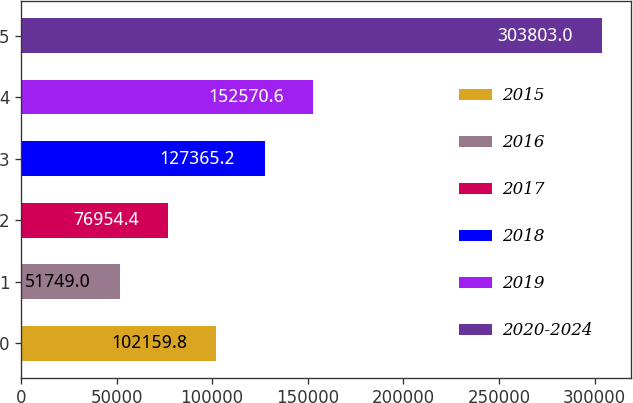Convert chart to OTSL. <chart><loc_0><loc_0><loc_500><loc_500><bar_chart><fcel>2015<fcel>2016<fcel>2017<fcel>2018<fcel>2019<fcel>2020-2024<nl><fcel>102160<fcel>51749<fcel>76954.4<fcel>127365<fcel>152571<fcel>303803<nl></chart> 